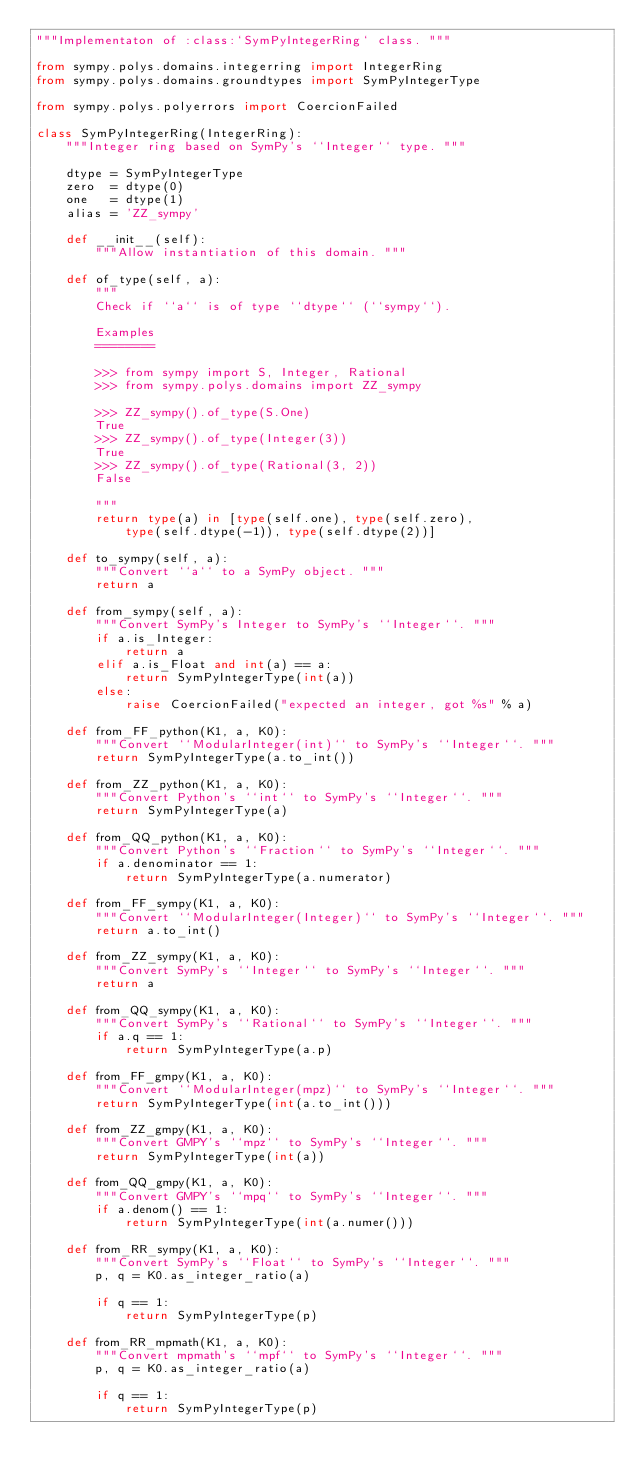Convert code to text. <code><loc_0><loc_0><loc_500><loc_500><_Python_>"""Implementaton of :class:`SymPyIntegerRing` class. """

from sympy.polys.domains.integerring import IntegerRing
from sympy.polys.domains.groundtypes import SymPyIntegerType

from sympy.polys.polyerrors import CoercionFailed

class SymPyIntegerRing(IntegerRing):
    """Integer ring based on SymPy's ``Integer`` type. """

    dtype = SymPyIntegerType
    zero  = dtype(0)
    one   = dtype(1)
    alias = 'ZZ_sympy'

    def __init__(self):
        """Allow instantiation of this domain. """

    def of_type(self, a):
        """
        Check if ``a`` is of type ``dtype`` (``sympy``).

        Examples
        ========

        >>> from sympy import S, Integer, Rational
        >>> from sympy.polys.domains import ZZ_sympy

        >>> ZZ_sympy().of_type(S.One)
        True
        >>> ZZ_sympy().of_type(Integer(3))
        True
        >>> ZZ_sympy().of_type(Rational(3, 2))
        False

        """
        return type(a) in [type(self.one), type(self.zero),
            type(self.dtype(-1)), type(self.dtype(2))]

    def to_sympy(self, a):
        """Convert ``a`` to a SymPy object. """
        return a

    def from_sympy(self, a):
        """Convert SymPy's Integer to SymPy's ``Integer``. """
        if a.is_Integer:
            return a
        elif a.is_Float and int(a) == a:
            return SymPyIntegerType(int(a))
        else:
            raise CoercionFailed("expected an integer, got %s" % a)

    def from_FF_python(K1, a, K0):
        """Convert ``ModularInteger(int)`` to SymPy's ``Integer``. """
        return SymPyIntegerType(a.to_int())

    def from_ZZ_python(K1, a, K0):
        """Convert Python's ``int`` to SymPy's ``Integer``. """
        return SymPyIntegerType(a)

    def from_QQ_python(K1, a, K0):
        """Convert Python's ``Fraction`` to SymPy's ``Integer``. """
        if a.denominator == 1:
            return SymPyIntegerType(a.numerator)

    def from_FF_sympy(K1, a, K0):
        """Convert ``ModularInteger(Integer)`` to SymPy's ``Integer``. """
        return a.to_int()

    def from_ZZ_sympy(K1, a, K0):
        """Convert SymPy's ``Integer`` to SymPy's ``Integer``. """
        return a

    def from_QQ_sympy(K1, a, K0):
        """Convert SymPy's ``Rational`` to SymPy's ``Integer``. """
        if a.q == 1:
            return SymPyIntegerType(a.p)

    def from_FF_gmpy(K1, a, K0):
        """Convert ``ModularInteger(mpz)`` to SymPy's ``Integer``. """
        return SymPyIntegerType(int(a.to_int()))

    def from_ZZ_gmpy(K1, a, K0):
        """Convert GMPY's ``mpz`` to SymPy's ``Integer``. """
        return SymPyIntegerType(int(a))

    def from_QQ_gmpy(K1, a, K0):
        """Convert GMPY's ``mpq`` to SymPy's ``Integer``. """
        if a.denom() == 1:
            return SymPyIntegerType(int(a.numer()))

    def from_RR_sympy(K1, a, K0):
        """Convert SymPy's ``Float`` to SymPy's ``Integer``. """
        p, q = K0.as_integer_ratio(a)

        if q == 1:
            return SymPyIntegerType(p)

    def from_RR_mpmath(K1, a, K0):
        """Convert mpmath's ``mpf`` to SymPy's ``Integer``. """
        p, q = K0.as_integer_ratio(a)

        if q == 1:
            return SymPyIntegerType(p)
</code> 